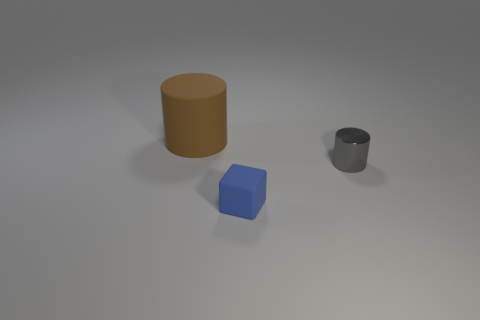What number of big objects are blue shiny blocks or blue rubber cubes?
Ensure brevity in your answer.  0. What number of brown things are there?
Make the answer very short. 1. What is the material of the cylinder to the right of the brown matte cylinder?
Give a very brief answer. Metal. Are there any big rubber objects to the left of the block?
Provide a short and direct response. Yes. Does the brown rubber cylinder have the same size as the rubber block?
Keep it short and to the point. No. How many large spheres are made of the same material as the small cube?
Make the answer very short. 0. What size is the rubber thing that is in front of the big cylinder that is behind the tiny matte block?
Your response must be concise. Small. There is a object that is both behind the small blue cube and in front of the big thing; what is its color?
Offer a very short reply. Gray. Is the shape of the large brown rubber thing the same as the tiny shiny thing?
Offer a terse response. Yes. What is the shape of the rubber object behind the tiny thing that is on the left side of the metal thing?
Ensure brevity in your answer.  Cylinder. 